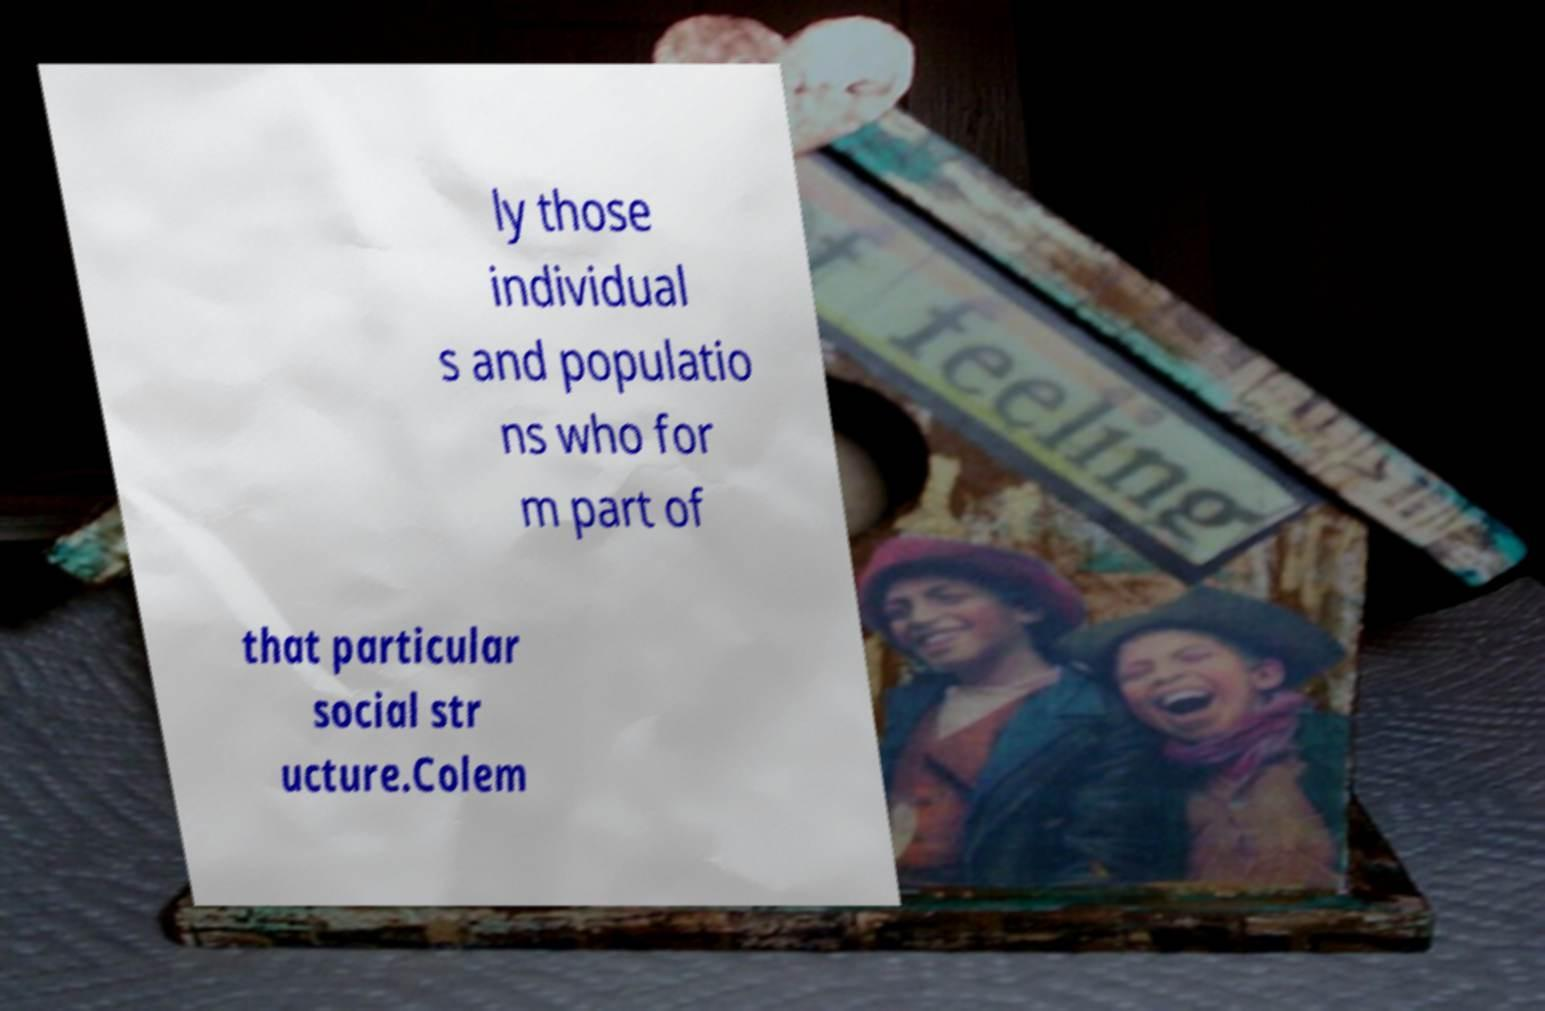I need the written content from this picture converted into text. Can you do that? ly those individual s and populatio ns who for m part of that particular social str ucture.Colem 